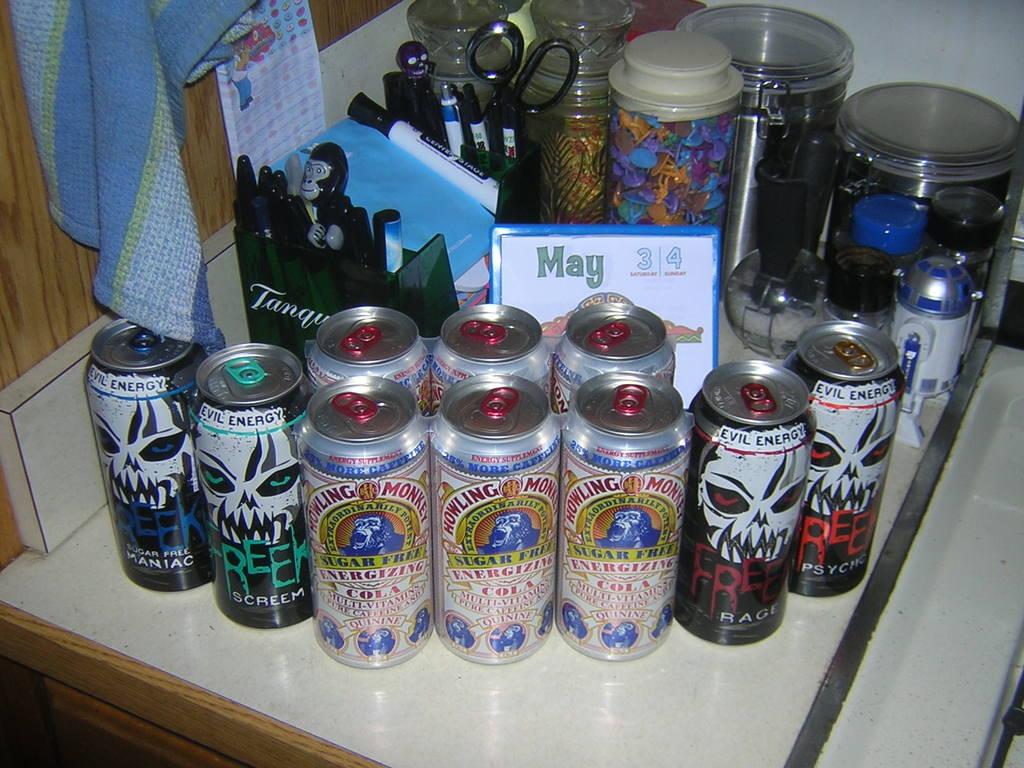What month is on the calendar?
Your answer should be very brief. May. What is the brand name of the cans with skulls on them?
Give a very brief answer. Evil energy. 